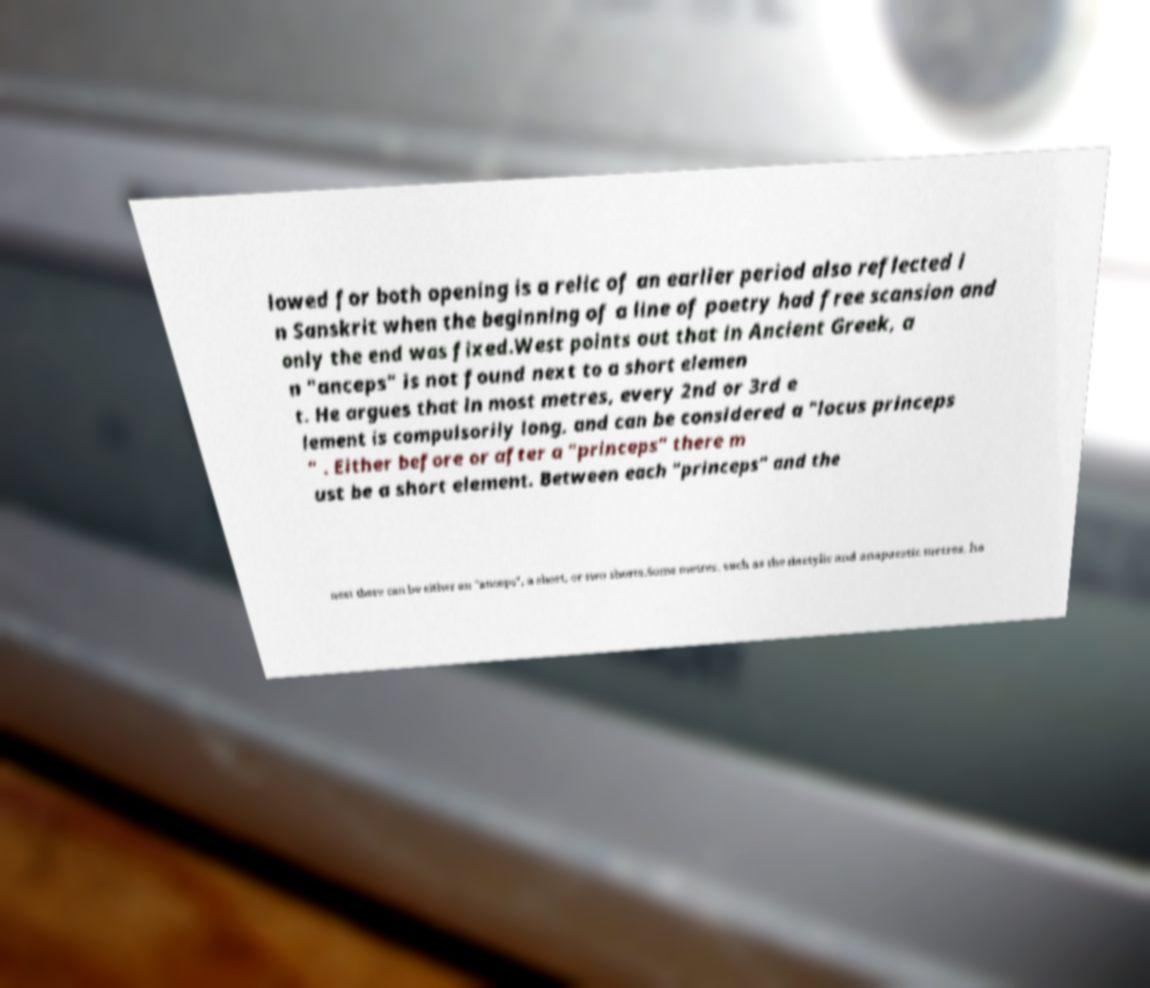Can you read and provide the text displayed in the image?This photo seems to have some interesting text. Can you extract and type it out for me? lowed for both opening is a relic of an earlier period also reflected i n Sanskrit when the beginning of a line of poetry had free scansion and only the end was fixed.West points out that in Ancient Greek, a n "anceps" is not found next to a short elemen t. He argues that in most metres, every 2nd or 3rd e lement is compulsorily long, and can be considered a "locus princeps " . Either before or after a "princeps" there m ust be a short element. Between each "princeps" and the next there can be either an "anceps", a short, or two shorts.Some metres, such as the dactylic and anapaestic metres, ha 